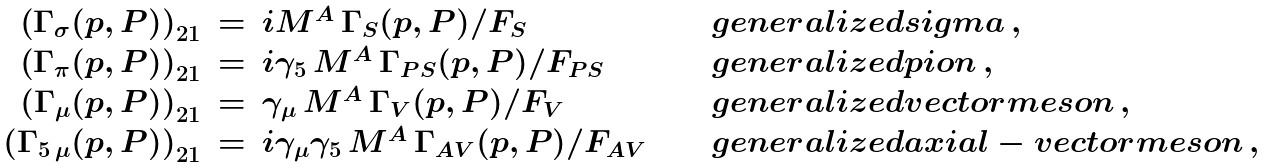Convert formula to latex. <formula><loc_0><loc_0><loc_500><loc_500>\begin{array} { r c l c l } \left ( \Gamma _ { \sigma } ( p , P ) \right ) _ { 2 1 } & = & i { M } ^ { A } \, \Gamma _ { S } ( p , P ) / F _ { S } & \quad & g e n e r a l i z e d s i g m a \, , \\ \left ( \Gamma _ { \pi } ( p , P ) \right ) _ { 2 1 } & = & i \gamma _ { 5 } \, { M } ^ { A } \, \Gamma _ { P S } ( p , P ) / F _ { P S } & \quad & g e n e r a l i z e d p i o n \, , \\ \left ( \Gamma _ { \mu } ( p , P ) \right ) _ { 2 1 } & = & \gamma _ { \mu } \, { M } ^ { A } \, \Gamma _ { V } ( p , P ) / F _ { V } & \quad & g e n e r a l i z e d v e c t o r m e s o n \, , \\ \left ( \Gamma _ { 5 \, \mu } ( p , P ) \right ) _ { 2 1 } & = & i \gamma _ { \mu } \gamma _ { 5 } \, { M } ^ { A } \, \Gamma _ { A V } ( p , P ) / F _ { A V } & \quad & g e n e r a l i z e d a x i a l - v e c t o r m e s o n \, , \\ \end{array}</formula> 